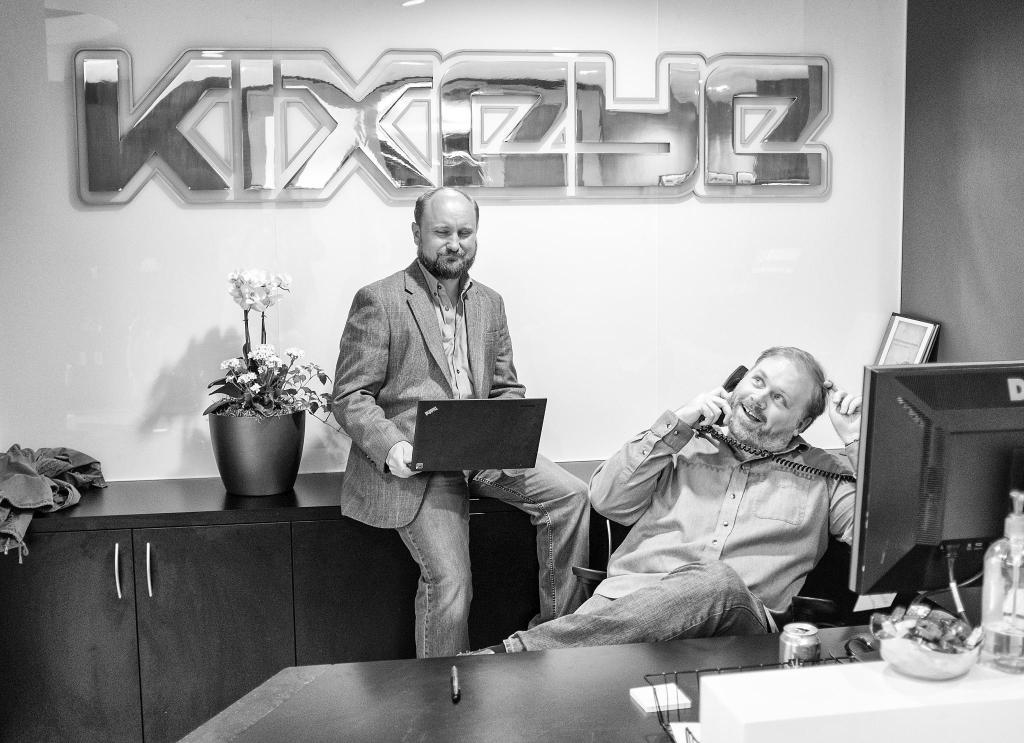How many people are present in the image? There are two people in the image. What is one person doing in the image? One person is sitting in front of a system. What is the other person holding in the image? The other person is holding a laptop. Can you describe any other objects in the image? There is a flower vase to the left in the image. What type of fan is visible in the image? There is no fan present in the image. How does the son in the image show respect to the other person? There is no son or indication of respect in the image. 